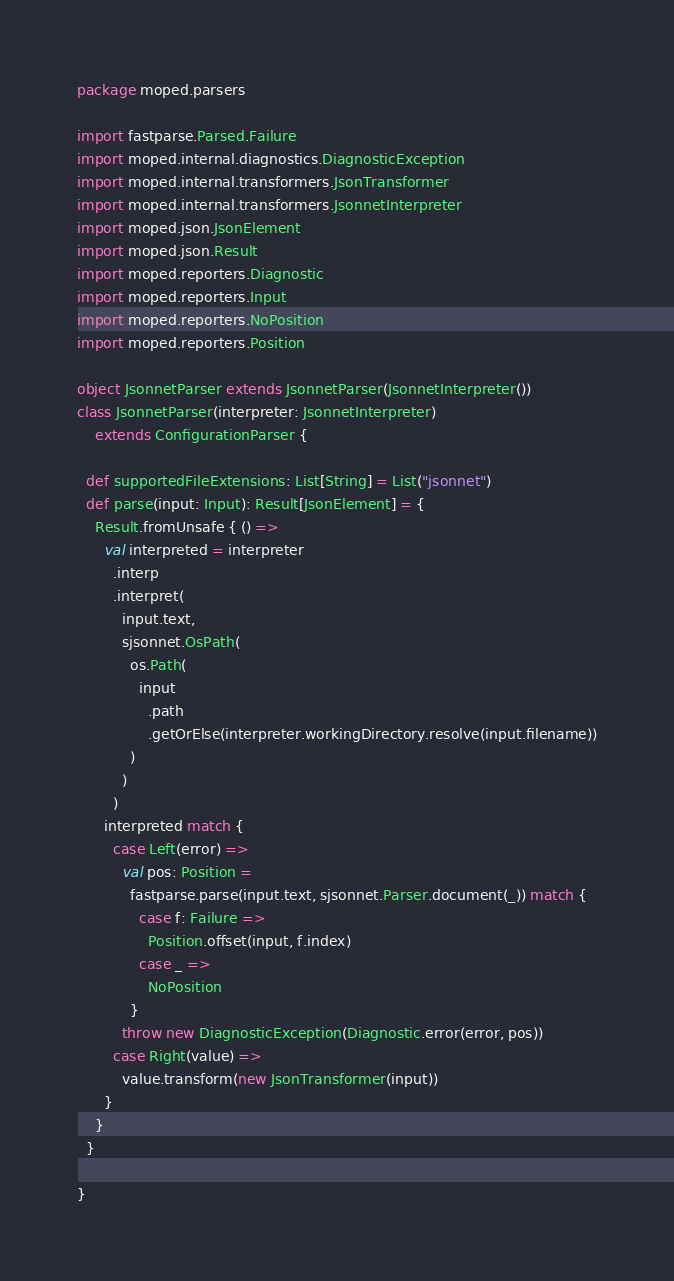<code> <loc_0><loc_0><loc_500><loc_500><_Scala_>package moped.parsers

import fastparse.Parsed.Failure
import moped.internal.diagnostics.DiagnosticException
import moped.internal.transformers.JsonTransformer
import moped.internal.transformers.JsonnetInterpreter
import moped.json.JsonElement
import moped.json.Result
import moped.reporters.Diagnostic
import moped.reporters.Input
import moped.reporters.NoPosition
import moped.reporters.Position

object JsonnetParser extends JsonnetParser(JsonnetInterpreter())
class JsonnetParser(interpreter: JsonnetInterpreter)
    extends ConfigurationParser {

  def supportedFileExtensions: List[String] = List("jsonnet")
  def parse(input: Input): Result[JsonElement] = {
    Result.fromUnsafe { () =>
      val interpreted = interpreter
        .interp
        .interpret(
          input.text,
          sjsonnet.OsPath(
            os.Path(
              input
                .path
                .getOrElse(interpreter.workingDirectory.resolve(input.filename))
            )
          )
        )
      interpreted match {
        case Left(error) =>
          val pos: Position =
            fastparse.parse(input.text, sjsonnet.Parser.document(_)) match {
              case f: Failure =>
                Position.offset(input, f.index)
              case _ =>
                NoPosition
            }
          throw new DiagnosticException(Diagnostic.error(error, pos))
        case Right(value) =>
          value.transform(new JsonTransformer(input))
      }
    }
  }

}
</code> 